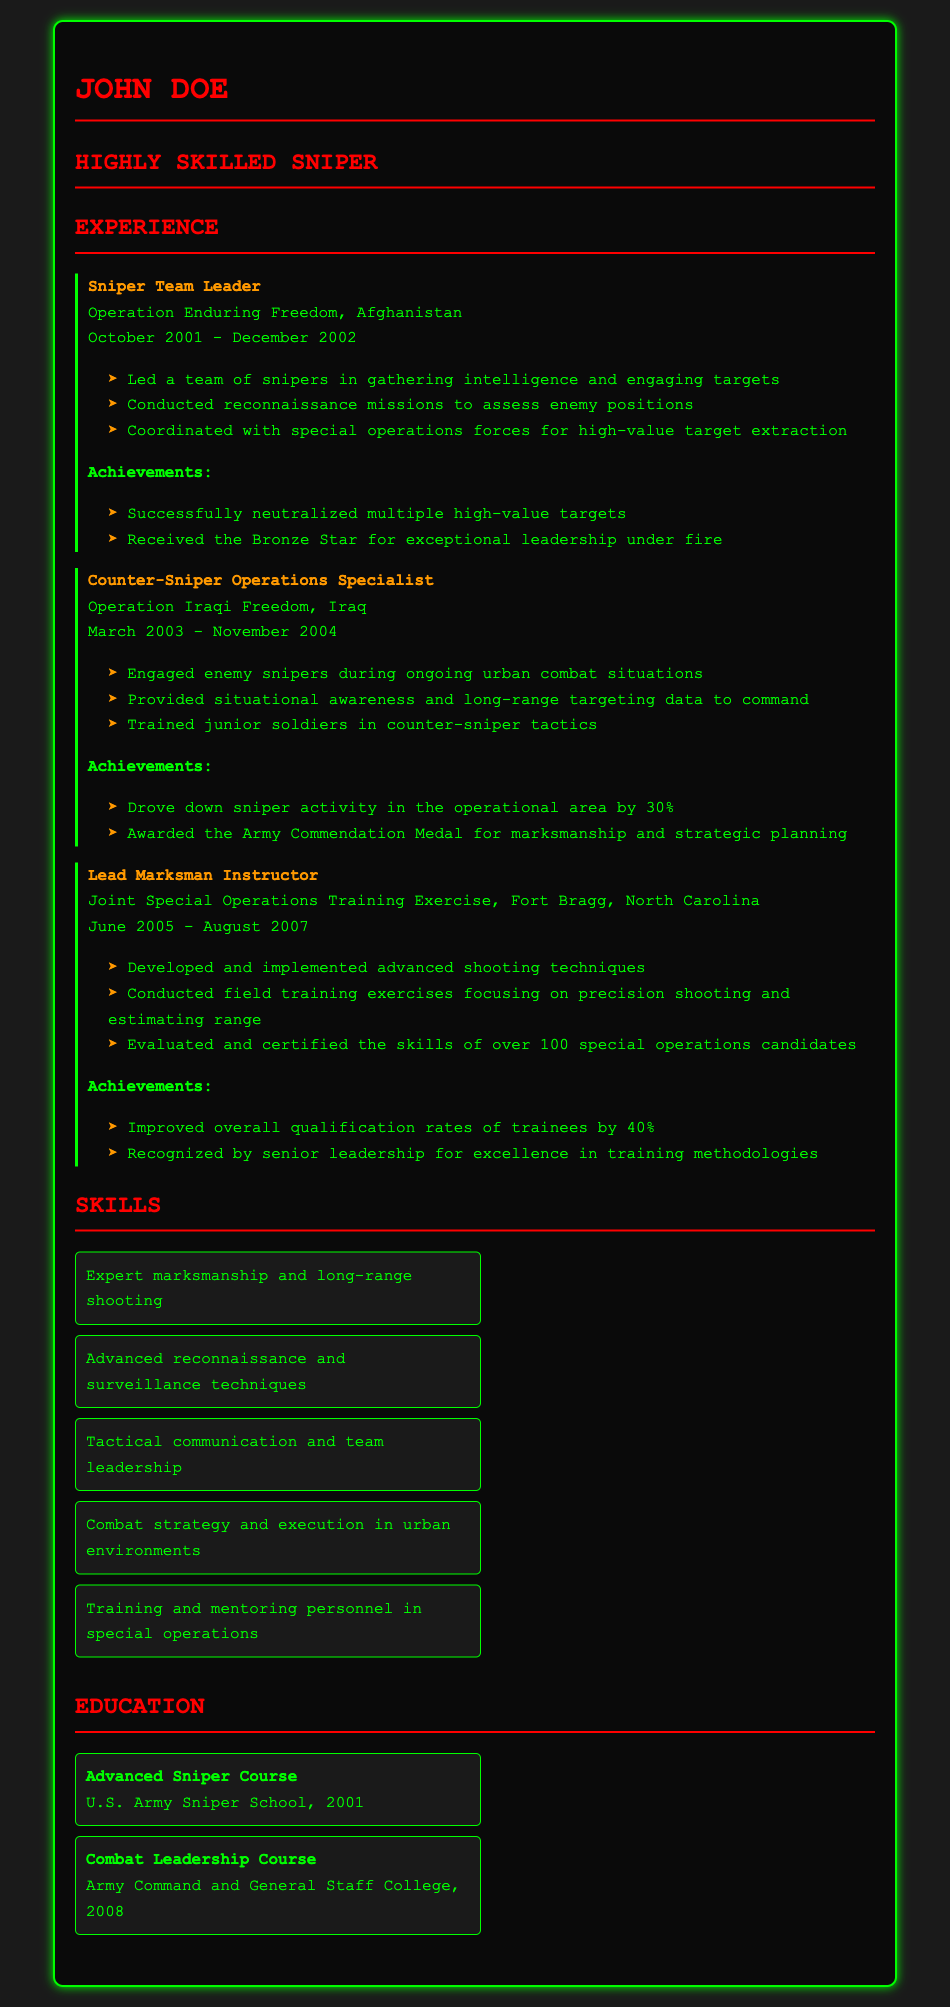What was the role of John Doe in Operation Enduring Freedom? The document states that John Doe was the Sniper Team Leader during Operation Enduring Freedom.
Answer: Sniper Team Leader In which country did John Doe serve during Operation Iraqi Freedom? The document mentions that Operation Iraqi Freedom took place in Iraq.
Answer: Iraq What recognition did John Doe receive for his leadership under fire? According to the document, he received the Bronze Star for exceptional leadership under fire.
Answer: Bronze Star How many special operations candidates did John Doe evaluate and certify as a Lead Marksman Instructor? The document indicates that he evaluated and certified over 100 special operations candidates.
Answer: Over 100 What was the duration of John Doe’s experience as a Counter-Sniper Operations Specialist? The document states that his experience lasted from March 2003 to November 2004, which is a diverse duration of 20 months.
Answer: 20 months What achievement did John Doe accomplish as a Lead Marksman Instructor? The document notes that he improved the overall qualification rates of trainees by 40%.
Answer: 40% How many key skills are listed in the document? Counting the entries in the skills section shows there are five key skills listed.
Answer: 5 What was John Doe's role in the Joint Special Operations Training Exercise? The document indicates he served as the Lead Marksman Instructor during this exercise.
Answer: Lead Marksman Instructor What techniques were developed by John Doe as a Lead Marksman Instructor? The document states that he developed and implemented advanced shooting techniques.
Answer: Advanced shooting techniques 